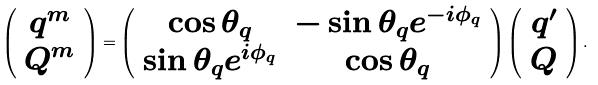<formula> <loc_0><loc_0><loc_500><loc_500>\left ( \begin{array} { c } q ^ { m } \\ Q ^ { m } \end{array} \right ) = \left ( \begin{array} { c c } \cos \theta _ { q } & - \sin \theta _ { q } e ^ { - i \phi _ { q } } \\ \sin \theta _ { q } e ^ { i \phi _ { q } } & \cos \theta _ { q } \end{array} \right ) \left ( \begin{array} { c } q ^ { \prime } \\ Q \end{array} \right ) .</formula> 